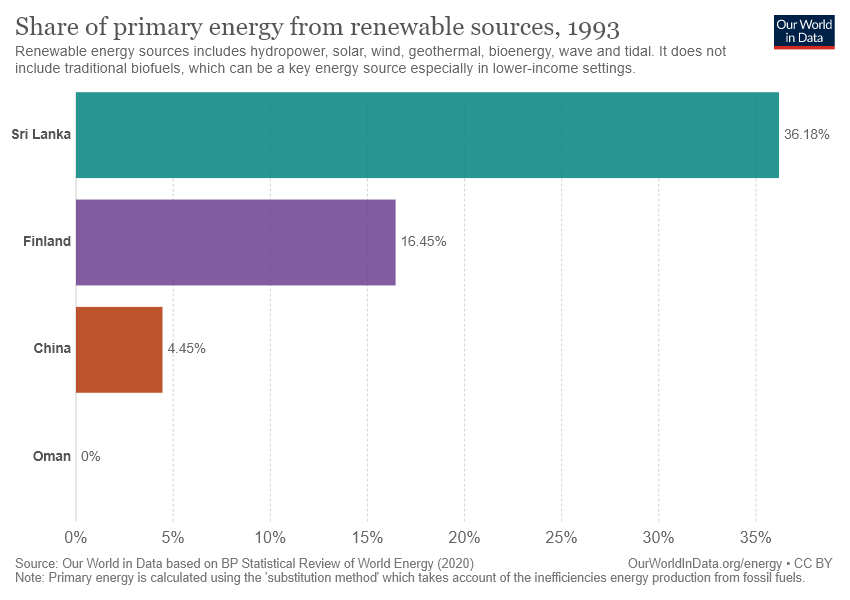Point out several critical features in this image. The color of the bar that represents China is brown. The sum of the value of China and Finland is greater than the difference of Sri Lanka and Finland. 